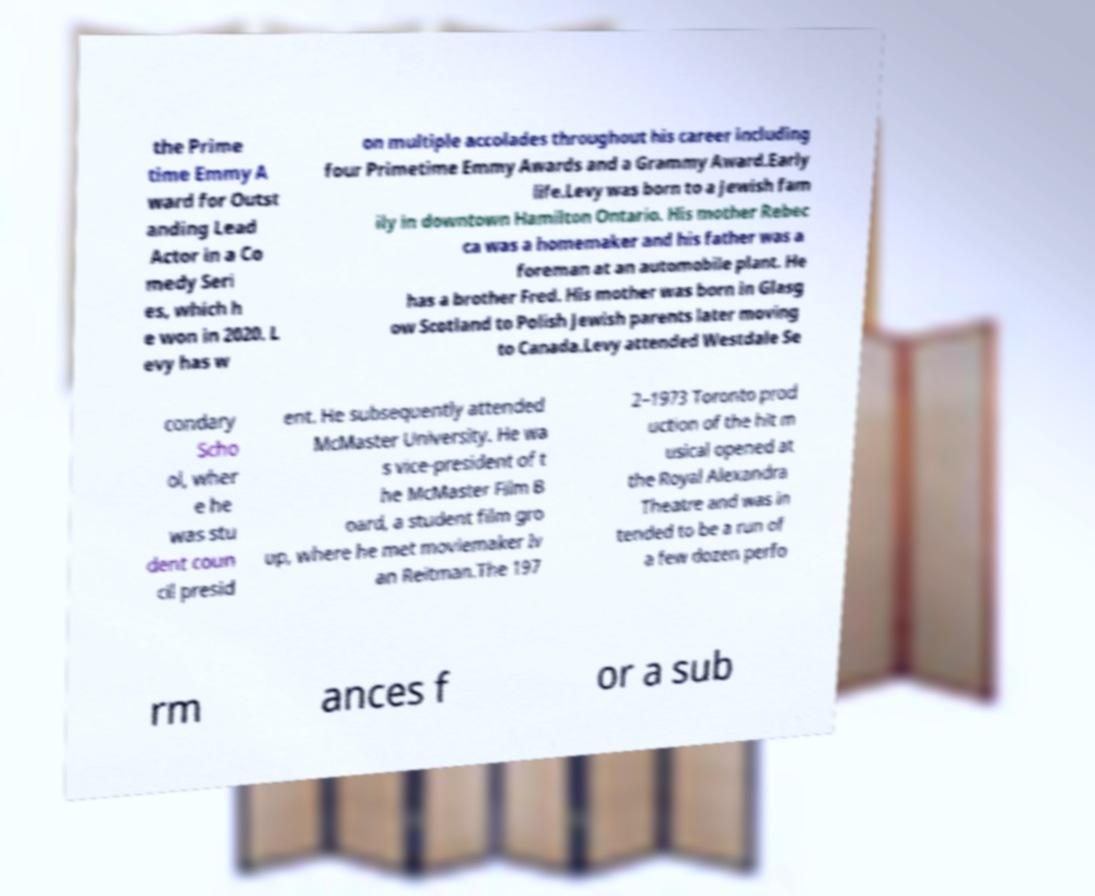Please read and relay the text visible in this image. What does it say? the Prime time Emmy A ward for Outst anding Lead Actor in a Co medy Seri es, which h e won in 2020. L evy has w on multiple accolades throughout his career including four Primetime Emmy Awards and a Grammy Award.Early life.Levy was born to a Jewish fam ily in downtown Hamilton Ontario. His mother Rebec ca was a homemaker and his father was a foreman at an automobile plant. He has a brother Fred. His mother was born in Glasg ow Scotland to Polish Jewish parents later moving to Canada.Levy attended Westdale Se condary Scho ol, wher e he was stu dent coun cil presid ent. He subsequently attended McMaster University. He wa s vice-president of t he McMaster Film B oard, a student film gro up, where he met moviemaker Iv an Reitman.The 197 2–1973 Toronto prod uction of the hit m usical opened at the Royal Alexandra Theatre and was in tended to be a run of a few dozen perfo rm ances f or a sub 